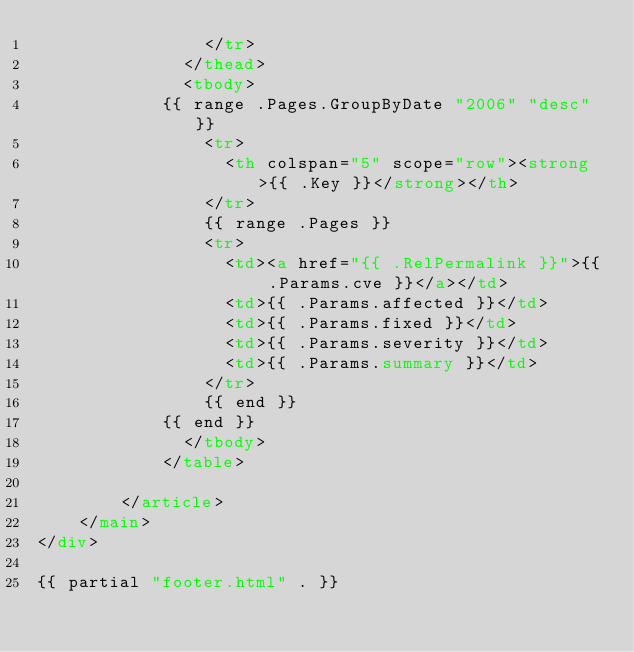<code> <loc_0><loc_0><loc_500><loc_500><_HTML_>                </tr>
              </thead>
              <tbody>
            {{ range .Pages.GroupByDate "2006" "desc" }}
                <tr>
                  <th colspan="5" scope="row"><strong>{{ .Key }}</strong></th>
                </tr>
                {{ range .Pages }}
                <tr>
                  <td><a href="{{ .RelPermalink }}">{{ .Params.cve }}</a></td>
                  <td>{{ .Params.affected }}</td>
                  <td>{{ .Params.fixed }}</td>
                  <td>{{ .Params.severity }}</td>
                  <td>{{ .Params.summary }}</td>
                </tr>
                {{ end }}
            {{ end }}
              </tbody>
            </table>

        </article>
    </main>
</div>

{{ partial "footer.html" . }}
</code> 